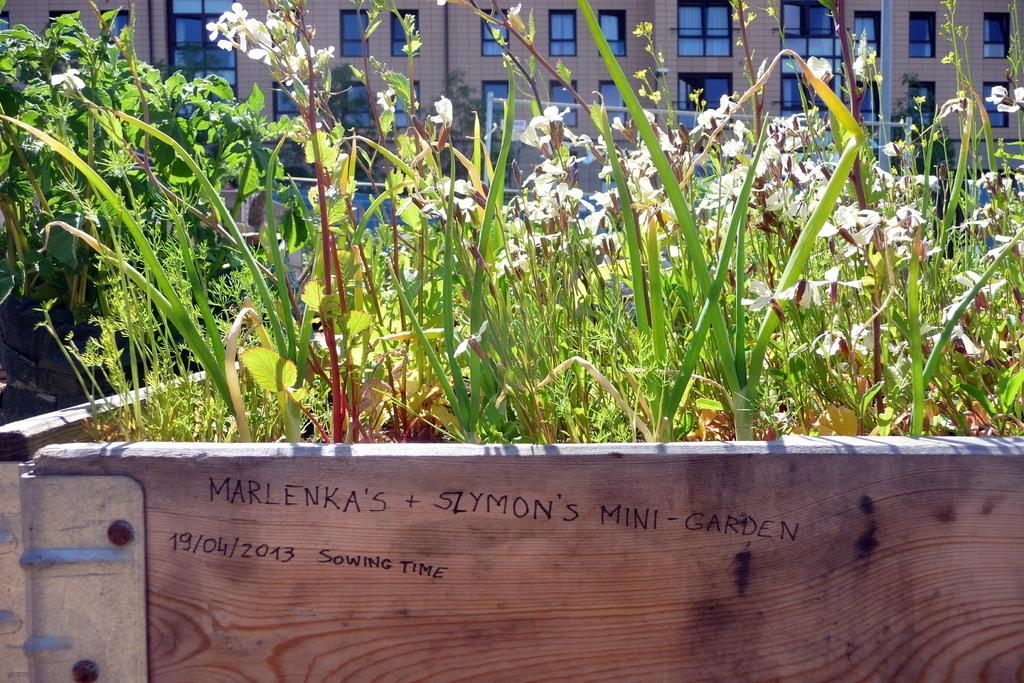What is the main subject in the center of the image? There are plants and flowers in the center of the image. What is written or displayed at the bottom of the image? There is a board with text at the bottom of the image. What type of structures can be seen at the top of the image? Buildings and windows are visible at the top of the image. What type of pan is being used to limit the burst of the flowers in the image? There is no pan or burst of flowers present in the image; it features plants and flowers in the center, a board with text at the bottom, and buildings and windows at the top. 